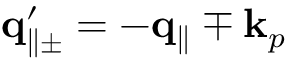<formula> <loc_0><loc_0><loc_500><loc_500>{ q } _ { \| \pm } ^ { \prime } = - { q } _ { \| } \mp { k } _ { p }</formula> 